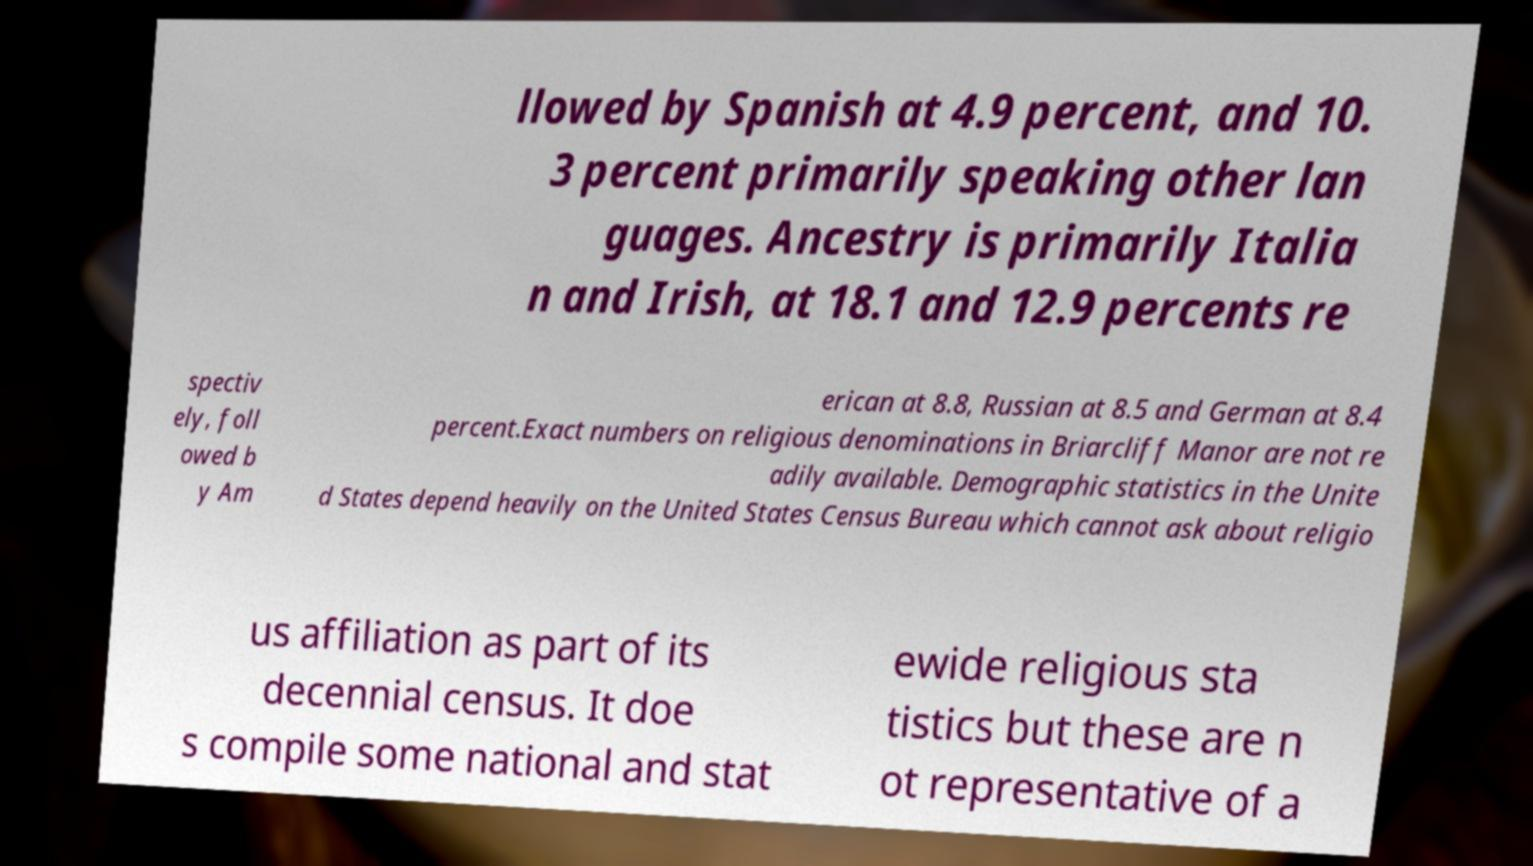Please identify and transcribe the text found in this image. llowed by Spanish at 4.9 percent, and 10. 3 percent primarily speaking other lan guages. Ancestry is primarily Italia n and Irish, at 18.1 and 12.9 percents re spectiv ely, foll owed b y Am erican at 8.8, Russian at 8.5 and German at 8.4 percent.Exact numbers on religious denominations in Briarcliff Manor are not re adily available. Demographic statistics in the Unite d States depend heavily on the United States Census Bureau which cannot ask about religio us affiliation as part of its decennial census. It doe s compile some national and stat ewide religious sta tistics but these are n ot representative of a 